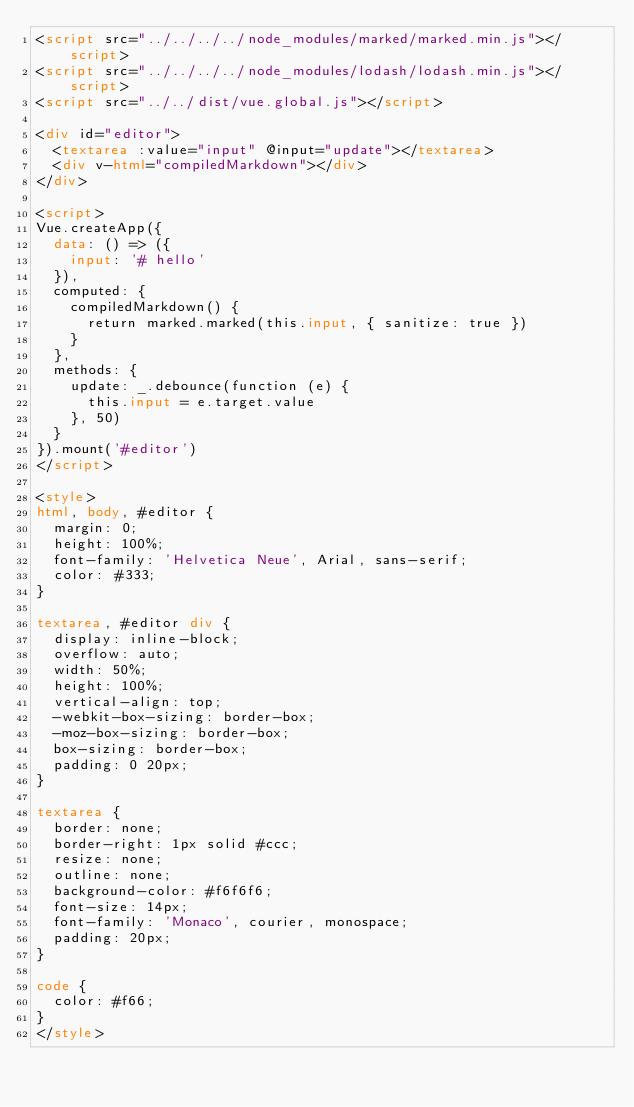<code> <loc_0><loc_0><loc_500><loc_500><_HTML_><script src="../../../../node_modules/marked/marked.min.js"></script>
<script src="../../../../node_modules/lodash/lodash.min.js"></script>
<script src="../../dist/vue.global.js"></script>

<div id="editor">
  <textarea :value="input" @input="update"></textarea>
  <div v-html="compiledMarkdown"></div>
</div>

<script>
Vue.createApp({
  data: () => ({
    input: '# hello'
  }),
  computed: {
    compiledMarkdown() {
      return marked.marked(this.input, { sanitize: true })
    }
  },
  methods: {
    update: _.debounce(function (e) {
      this.input = e.target.value
    }, 50)
  }
}).mount('#editor')
</script>

<style>
html, body, #editor {
  margin: 0;
  height: 100%;
  font-family: 'Helvetica Neue', Arial, sans-serif;
  color: #333;
}

textarea, #editor div {
  display: inline-block;
  overflow: auto;
  width: 50%;
  height: 100%;
  vertical-align: top;
  -webkit-box-sizing: border-box;
  -moz-box-sizing: border-box;
  box-sizing: border-box;
  padding: 0 20px;
}

textarea {
  border: none;
  border-right: 1px solid #ccc;
  resize: none;
  outline: none;
  background-color: #f6f6f6;
  font-size: 14px;
  font-family: 'Monaco', courier, monospace;
  padding: 20px;
}

code {
  color: #f66;
}
</style>
</code> 